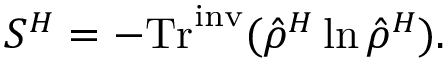<formula> <loc_0><loc_0><loc_500><loc_500>S ^ { H } = - T r ^ { i n v } ( \hat { \rho } ^ { H } \ln \hat { \rho } ^ { H } ) .</formula> 